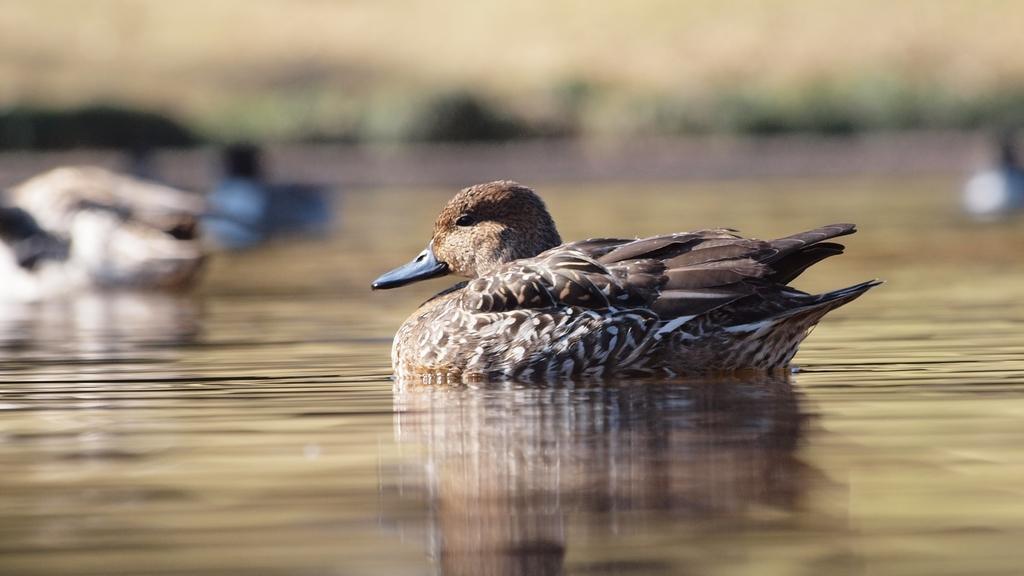Describe this image in one or two sentences. In the center of the image, we can see a duck on the water. 